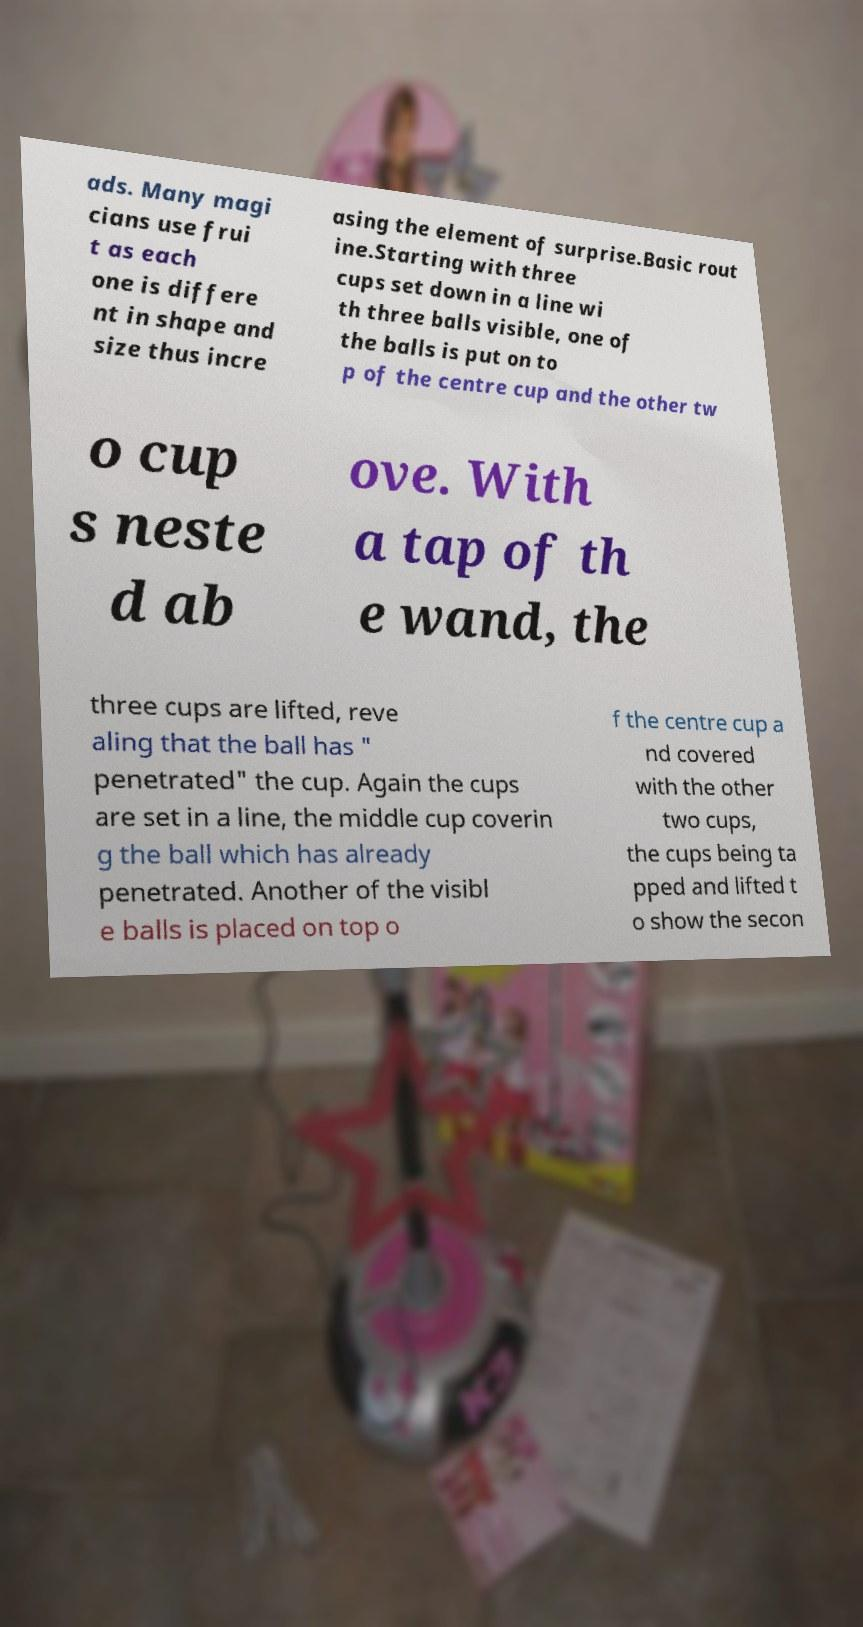Can you accurately transcribe the text from the provided image for me? ads. Many magi cians use frui t as each one is differe nt in shape and size thus incre asing the element of surprise.Basic rout ine.Starting with three cups set down in a line wi th three balls visible, one of the balls is put on to p of the centre cup and the other tw o cup s neste d ab ove. With a tap of th e wand, the three cups are lifted, reve aling that the ball has " penetrated" the cup. Again the cups are set in a line, the middle cup coverin g the ball which has already penetrated. Another of the visibl e balls is placed on top o f the centre cup a nd covered with the other two cups, the cups being ta pped and lifted t o show the secon 